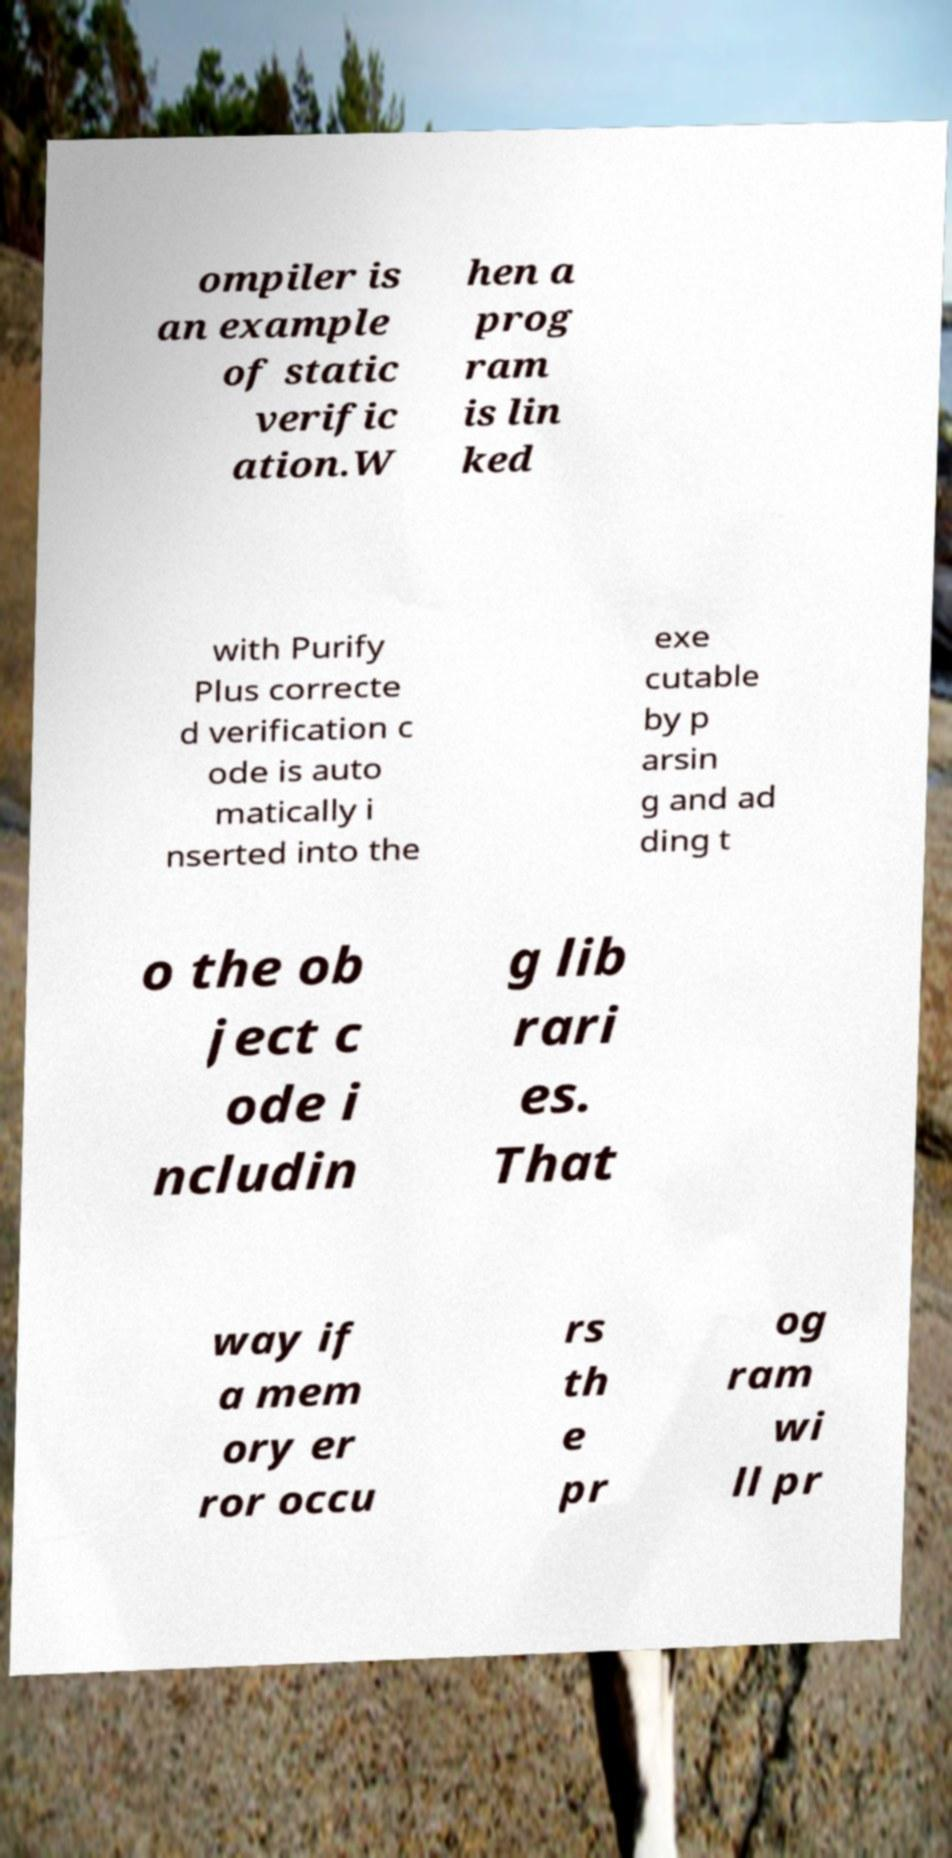There's text embedded in this image that I need extracted. Can you transcribe it verbatim? ompiler is an example of static verific ation.W hen a prog ram is lin ked with Purify Plus correcte d verification c ode is auto matically i nserted into the exe cutable by p arsin g and ad ding t o the ob ject c ode i ncludin g lib rari es. That way if a mem ory er ror occu rs th e pr og ram wi ll pr 